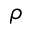<formula> <loc_0><loc_0><loc_500><loc_500>\rho</formula> 